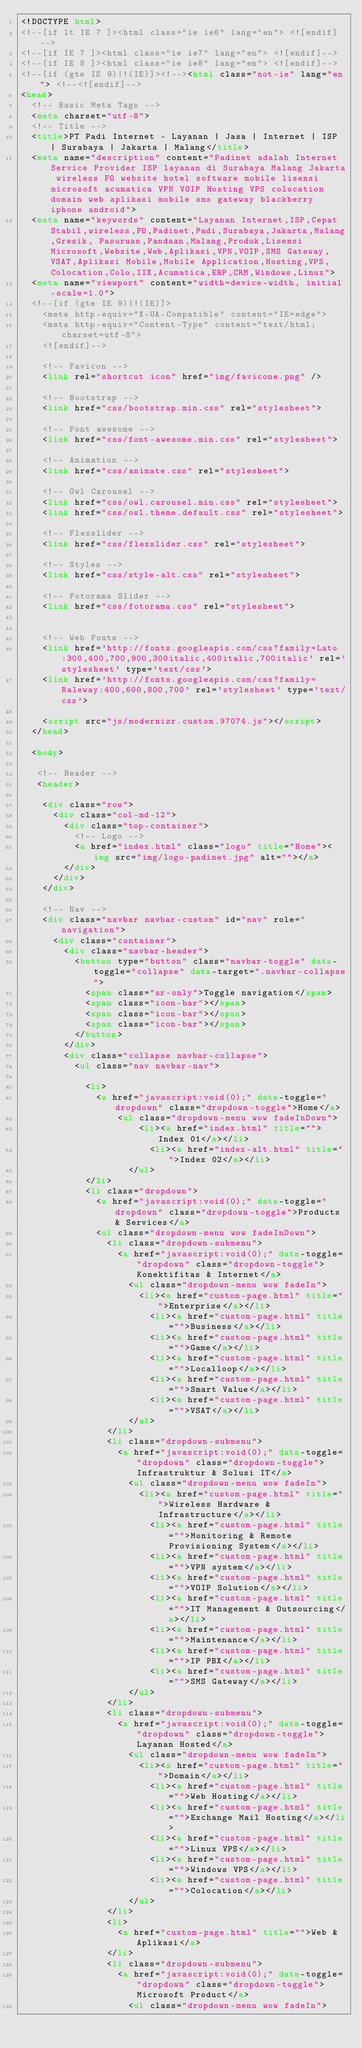Convert code to text. <code><loc_0><loc_0><loc_500><loc_500><_HTML_><!DOCTYPE html>
<!--[if lt IE 7 ]><html class="ie ie6" lang="en"> <![endif]-->
<!--[if IE 7 ]><html class="ie ie7" lang="en"> <![endif]-->
<!--[if IE 8 ]><html class="ie ie8" lang="en"> <![endif]-->
<!--[if (gte IE 9)|!(IE)]><!--><html class="not-ie" lang="en"> <!--<![endif]-->
<head>
  <!-- Basic Meta Tags -->
  <meta charset="utf-8">
  <!-- Title -->
  <title>PT Padi Internet - Layanan | Jasa | Internet | ISP | Surabaya | Jakarta | Malang</title>
  <meta name="description" content="Padinet adalah Internet Service Provider ISP layanan di Surabaya Malang Jakarta wireless FO website hotel software mobile lisensi microsoft acumatica VPN VOIP Hosting VPS colocation domain web aplikasi mobile sms gateway blackberry iphone android">
  <meta name="keywords" content="Layanan Internet,ISP,Cepat Stabil,wireless,FO,Padinet,Padi,Surabaya,Jakarta,Malang,Gresik, Pasuruan,Pandaan,Malang,Produk,Lisensi Microsoft,Website,Web,Aplikasi,VPN,VOIP,SMS Gateway,VSAT,Aplikasi Mobile,Mobile Application,Hosting,VPS,Colocation,Colo,IIX,Acumatica,ERP,CRM,Windows,Linux">
  <meta name="viewport" content="width=device-width, initial-scale=1.0">
  <!--[if (gte IE 9)|!(IE)]>
    <meta http-equiv="X-UA-Compatible" content="IE=edge">
    <meta http-equiv="Content-Type" content="text/html;charset=utf-8"> 
    <![endif]--> 

    <!-- Favicon -->
    <link rel="shortcut icon" href="img/favicone.png" />

    <!-- Bootstrap -->
    <link href="css/bootstrap.min.css" rel="stylesheet">

    <!-- Font awesome -->
    <link href="css/font-awesome.min.css" rel="stylesheet"> 

    <!-- Animation -->
    <link href="css/animate.css" rel="stylesheet">

    <!-- Owl Carousel -->
    <link href="css/owl.carousel.min.css" rel="stylesheet">
    <link href="css/owl.theme.default.css" rel="stylesheet">

    <!-- Flexslider -->
    <link href="css/flexslider.css" rel="stylesheet"> 

    <!-- Styles -->
    <link href="css/style-alt.css" rel="stylesheet">

    <!-- Fotorama Slider -->
    <link href="css/fotorama.css" rel="stylesheet">


    <!-- Web Fonts -->
    <link href='http://fonts.googleapis.com/css?family=Lato:300,400,700,900,300italic,400italic,700italic' rel='stylesheet' type='text/css'>
    <link href='http://fonts.googleapis.com/css?family=Raleway:400,600,800,700' rel='stylesheet' type='text/css'>

    <script src="js/modernizr.custom.97074.js"></script>
  </head>

  <body>

   <!-- Header -->
   <header> 

    <div class="row">
      <div class="col-md-12">
        <div class="top-container">
          <!-- Logo -->                       
          <a href="index.html" class="logo" title="Home"><img src="img/logo-padinet.jpg" alt=""></a>
        </div>
      </div> 
    </div> 

    <!-- Nav -->
    <div class="navbar navbar-custom" id="nav" role="navigation">
      <div class="container">
        <div class="navbar-header">
          <button type="button" class="navbar-toggle" data-toggle="collapse" data-target=".navbar-collapse">
            <span class="sr-only">Toggle navigation</span>
            <span class="icon-bar"></span>
            <span class="icon-bar"></span>
            <span class="icon-bar"></span>
          </button>
        </div>
        <div class="collapse navbar-collapse">
          <ul class="nav navbar-nav">

            <li>
              <a href="javascript:void(0);" data-toggle="dropdown" class="dropdown-toggle">Home</a>
              		<ul class="dropdown-menu wow fadeInDown">
                    	<li><a href="index.html" title="">Index 01</a></li>
                        <li><a href="index-alt.html" title="">Index 02</a></li>
                    </ul>
            </li>
            <li class="dropdown">
              <a href="javascript:void(0);" data-toggle="dropdown" class="dropdown-toggle">Products & Services</a>
              <ul class="dropdown-menu wow fadeInDown">
                <li class="dropdown-submenu">
                  <a href="javascript:void(0);" data-toggle="dropdown" class="dropdown-toggle">Konektifitas & Internet</a>
                  	<ul class="dropdown-menu wow fadeIn">
                    	<li><a href="custom-page.html" title="">Enterprise</a></li>
                        <li><a href="custom-page.html" title="">Business</a></li>
                        <li><a href="custom-page.html" title="">Game</a></li>
                        <li><a href="custom-page.html" title="">Localloop</a></li>
                        <li><a href="custom-page.html" title="">Smart Value</a></li>
                        <li><a href="custom-page.html" title="">VSAT</a></li>
                    </ul>
                </li>
                <li class="dropdown-submenu">
                  <a href="javascript:void(0);" data-toggle="dropdown" class="dropdown-toggle">Infrastruktur & Solusi IT</a>
                  	<ul class="dropdown-menu wow fadeIn">
                    	<li><a href="custom-page.html" title="">Wireless Hardware & Infrastructure</a></li>
                        <li><a href="custom-page.html" title="">Monitoring & Remote Provisioning System</a></li>
                        <li><a href="custom-page.html" title="">VPN system</a></li>
                        <li><a href="custom-page.html" title="">VOIP Solution</a></li>
                        <li><a href="custom-page.html" title="">IT Management & Outsourcing</a></li>
                        <li><a href="custom-page.html" title="">Maintenance</a></li>
                        <li><a href="custom-page.html" title="">IP PBX</a></li>
                        <li><a href="custom-page.html" title="">SMS Gateway</a></li>
                    </ul>
                </li>
                <li class="dropdown-submenu">
                  <a href="javascript:void(0);" data-toggle="dropdown" class="dropdown-toggle">Layanan Hosted</a>
                  	<ul class="dropdown-menu wow fadeIn">
                    	<li><a href="custom-page.html" title="">Domain</a></li>
                        <li><a href="custom-page.html" title="">Web Hosting</a></li>
                        <li><a href="custom-page.html" title="">Exchange Mail Hosting</a></li>
                        <li><a href="custom-page.html" title="">Linux VPS</a></li>
                        <li><a href="custom-page.html" title="">Windows VPS</a></li>
                        <li><a href="custom-page.html" title="">Colocation</a></li>
                    </ul>
                </li>
                <li>
                  <a href="custom-page.html" title="">Web & Aplikasi</a>
                </li>
                <li class="dropdown-submenu">
                  <a href="javascript:void(0);" data-toggle="dropdown" class="dropdown-toggle">Microsoft Product</a>
                  	<ul class="dropdown-menu wow fadeIn"></code> 